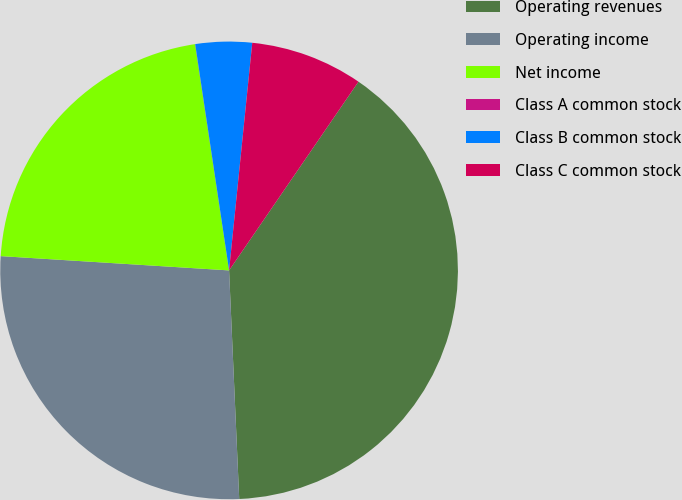<chart> <loc_0><loc_0><loc_500><loc_500><pie_chart><fcel>Operating revenues<fcel>Operating income<fcel>Net income<fcel>Class A common stock<fcel>Class B common stock<fcel>Class C common stock<nl><fcel>39.73%<fcel>26.7%<fcel>21.63%<fcel>0.01%<fcel>3.98%<fcel>7.95%<nl></chart> 